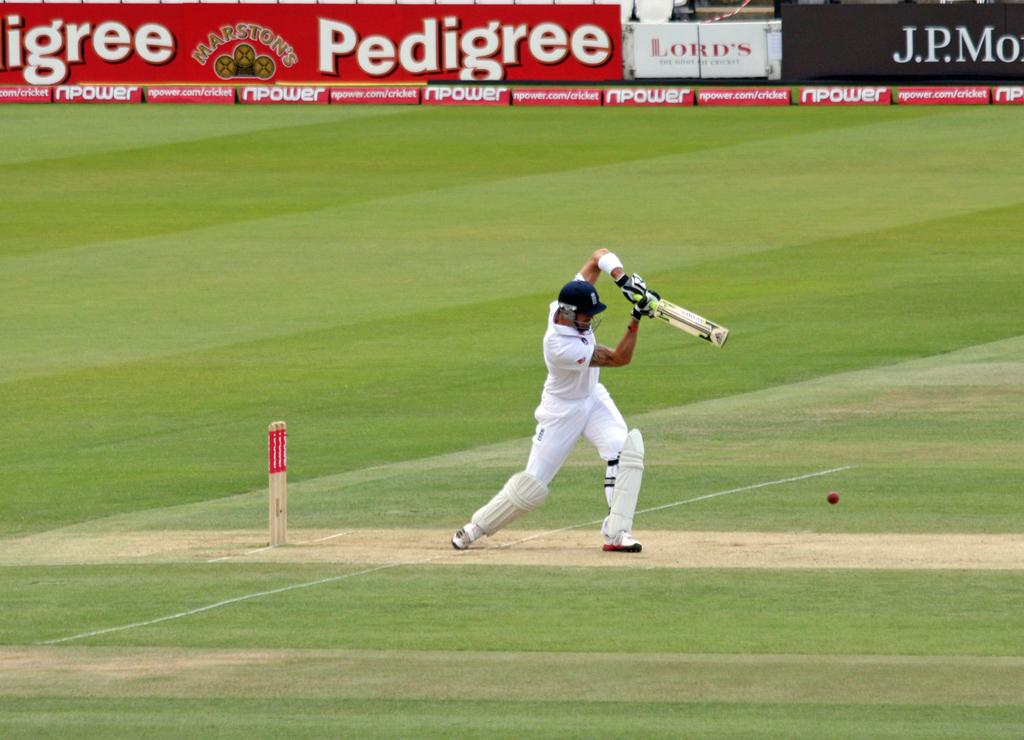<image>
Give a short and clear explanation of the subsequent image. A cricket player is shown on the field with advertisements on the wall for Pedigree and J.P. Morgan. 